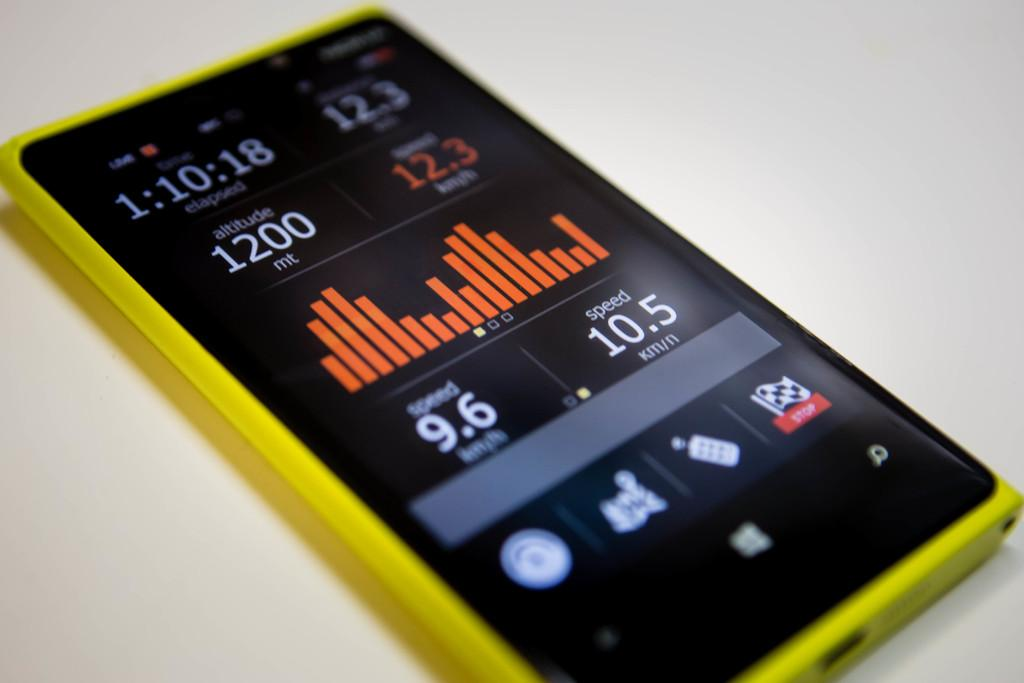<image>
Describe the image concisely. Black and yellow phone that says 12.3 in orange. 